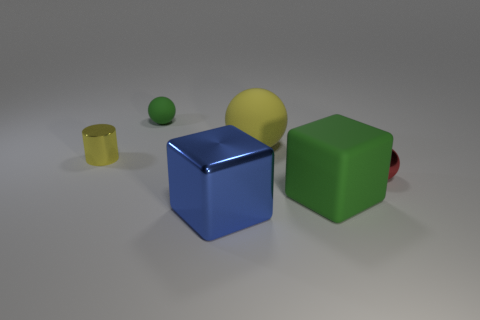Is the color of the tiny rubber sphere the same as the rubber cube?
Keep it short and to the point. Yes. What is the color of the object that is behind the large matte object behind the red shiny thing?
Provide a succinct answer. Green. Are there any tiny shiny objects of the same color as the large rubber sphere?
Your answer should be very brief. Yes. What number of metal objects are either small brown cylinders or blue objects?
Offer a very short reply. 1. Are there any blue cylinders made of the same material as the tiny red object?
Provide a succinct answer. No. What number of large things are both behind the green matte cube and in front of the yellow rubber sphere?
Provide a succinct answer. 0. Is the number of small red shiny objects that are left of the tiny red shiny object less than the number of big green cubes left of the matte cube?
Give a very brief answer. No. Is the shape of the large metallic object the same as the tiny yellow thing?
Offer a terse response. No. How many other things are there of the same size as the blue thing?
Give a very brief answer. 2. How many things are tiny balls behind the tiny yellow metal object or tiny red metallic things that are on the right side of the cylinder?
Your response must be concise. 2. 